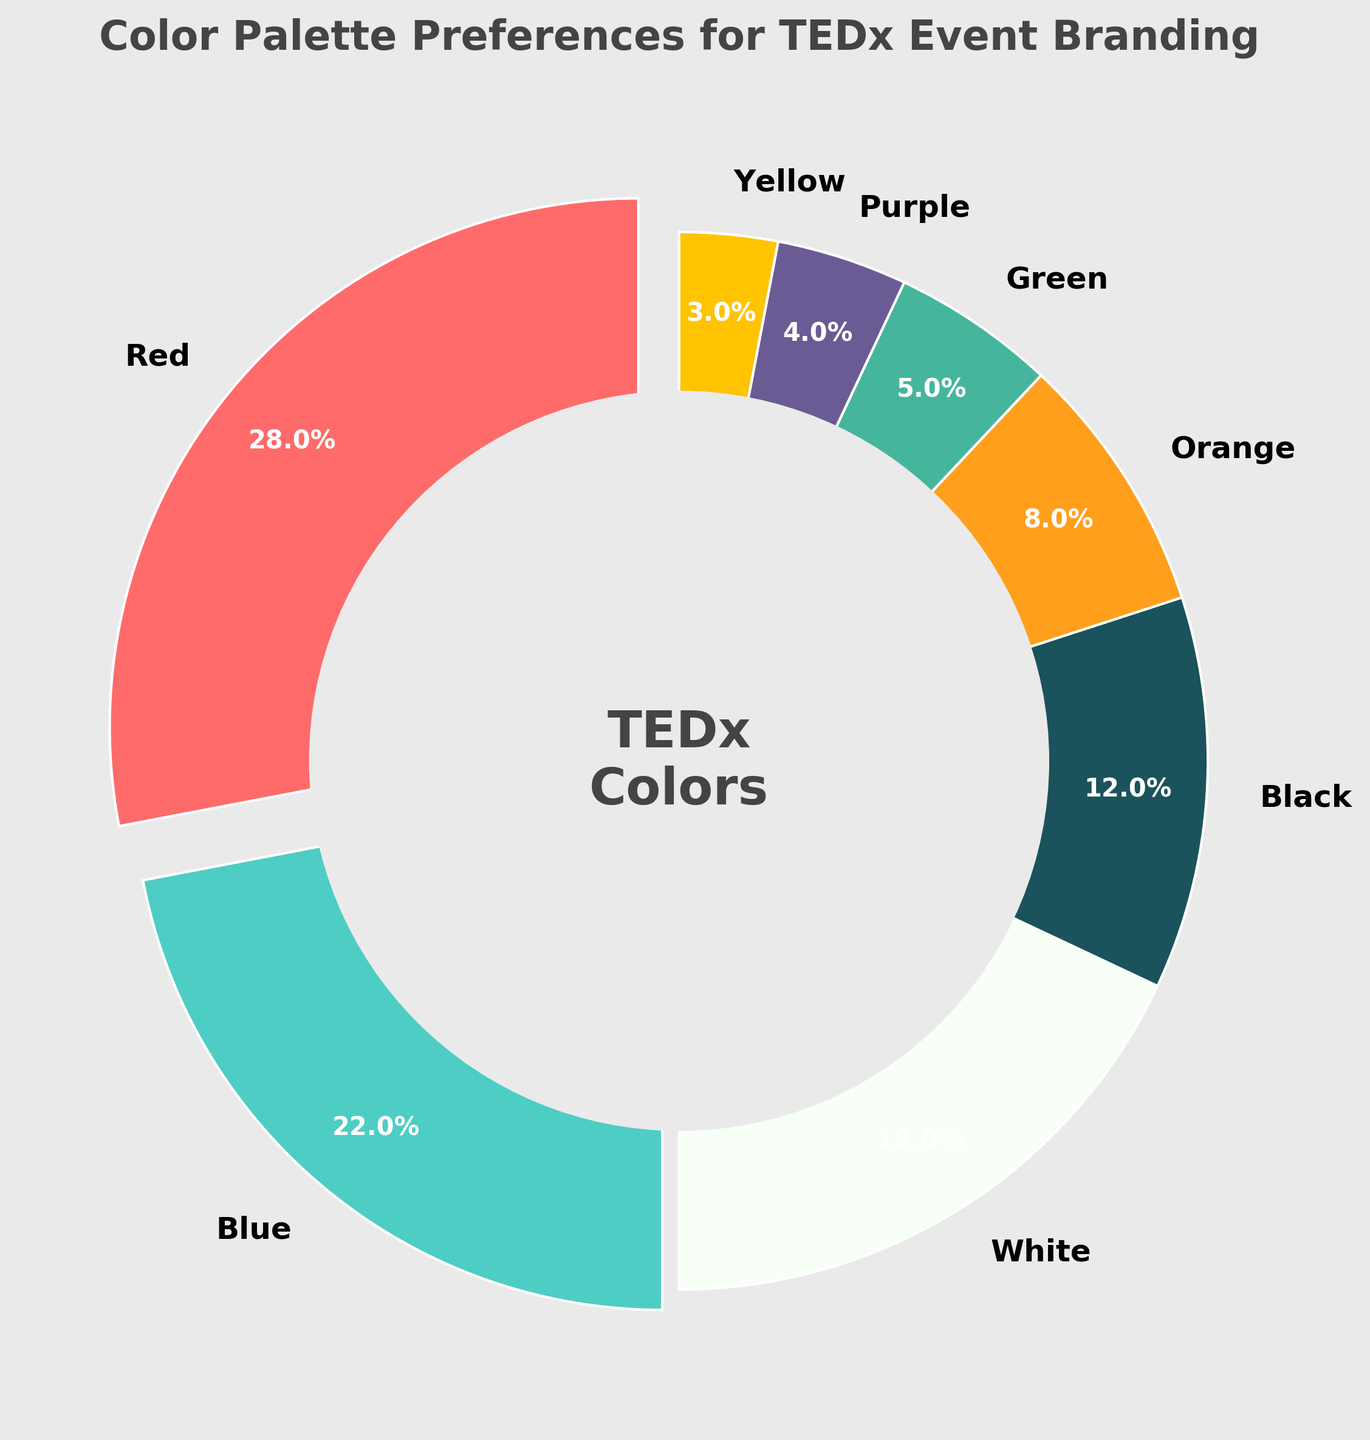What is the most preferred color for TEDx event branding from the given data? The slice with the largest percentage indicates the most preferred color. From the chart, the largest slice, representing 28%, corresponds to Red.
Answer: Red How much more preferred is Red compared to Blue? Red has a preference percentage of 28%, and Blue has 22%. Subtracting Blue's percentage from Red's gives 28% - 22% = 6%.
Answer: 6% Which color occupies the smallest portion of the pie chart? The smallest slice in the pie chart represents 3%, which corresponds to Yellow.
Answer: Yellow What is the combined preference percentage for White, Black, and Green? From the chart, White is 18%, Black is 12%, and Green is 5%. Summing these values gives 18% + 12% + 5% = 35%.
Answer: 35% Is Red preferred more than Orange and Blue combined? Orange and Blue together have percentages of 8% and 22%, respectively. Summing these gives 8% + 22% = 30%. Red's preference is 28%, which is less than 30%.
Answer: No What is the combined preference percentage of colors that individually have less than 10% preference? From the chart, the colors with less than 10% are Orange (8%), Green (5%), Purple (4%), and Yellow (3%). Summing these values gives 8% + 5% + 4% + 3% = 20%.
Answer: 20% How much percentage more is White preferred over Purple? White has 18%, and Purple has 4%. Subtracting Purple's percentage from White's gives 18% - 4% = 14%.
Answer: 14% Which two colors have the closest preference percentages? Blue with 22% and White with 18% are the closest, the difference being 4%.
Answer: Blue and White 